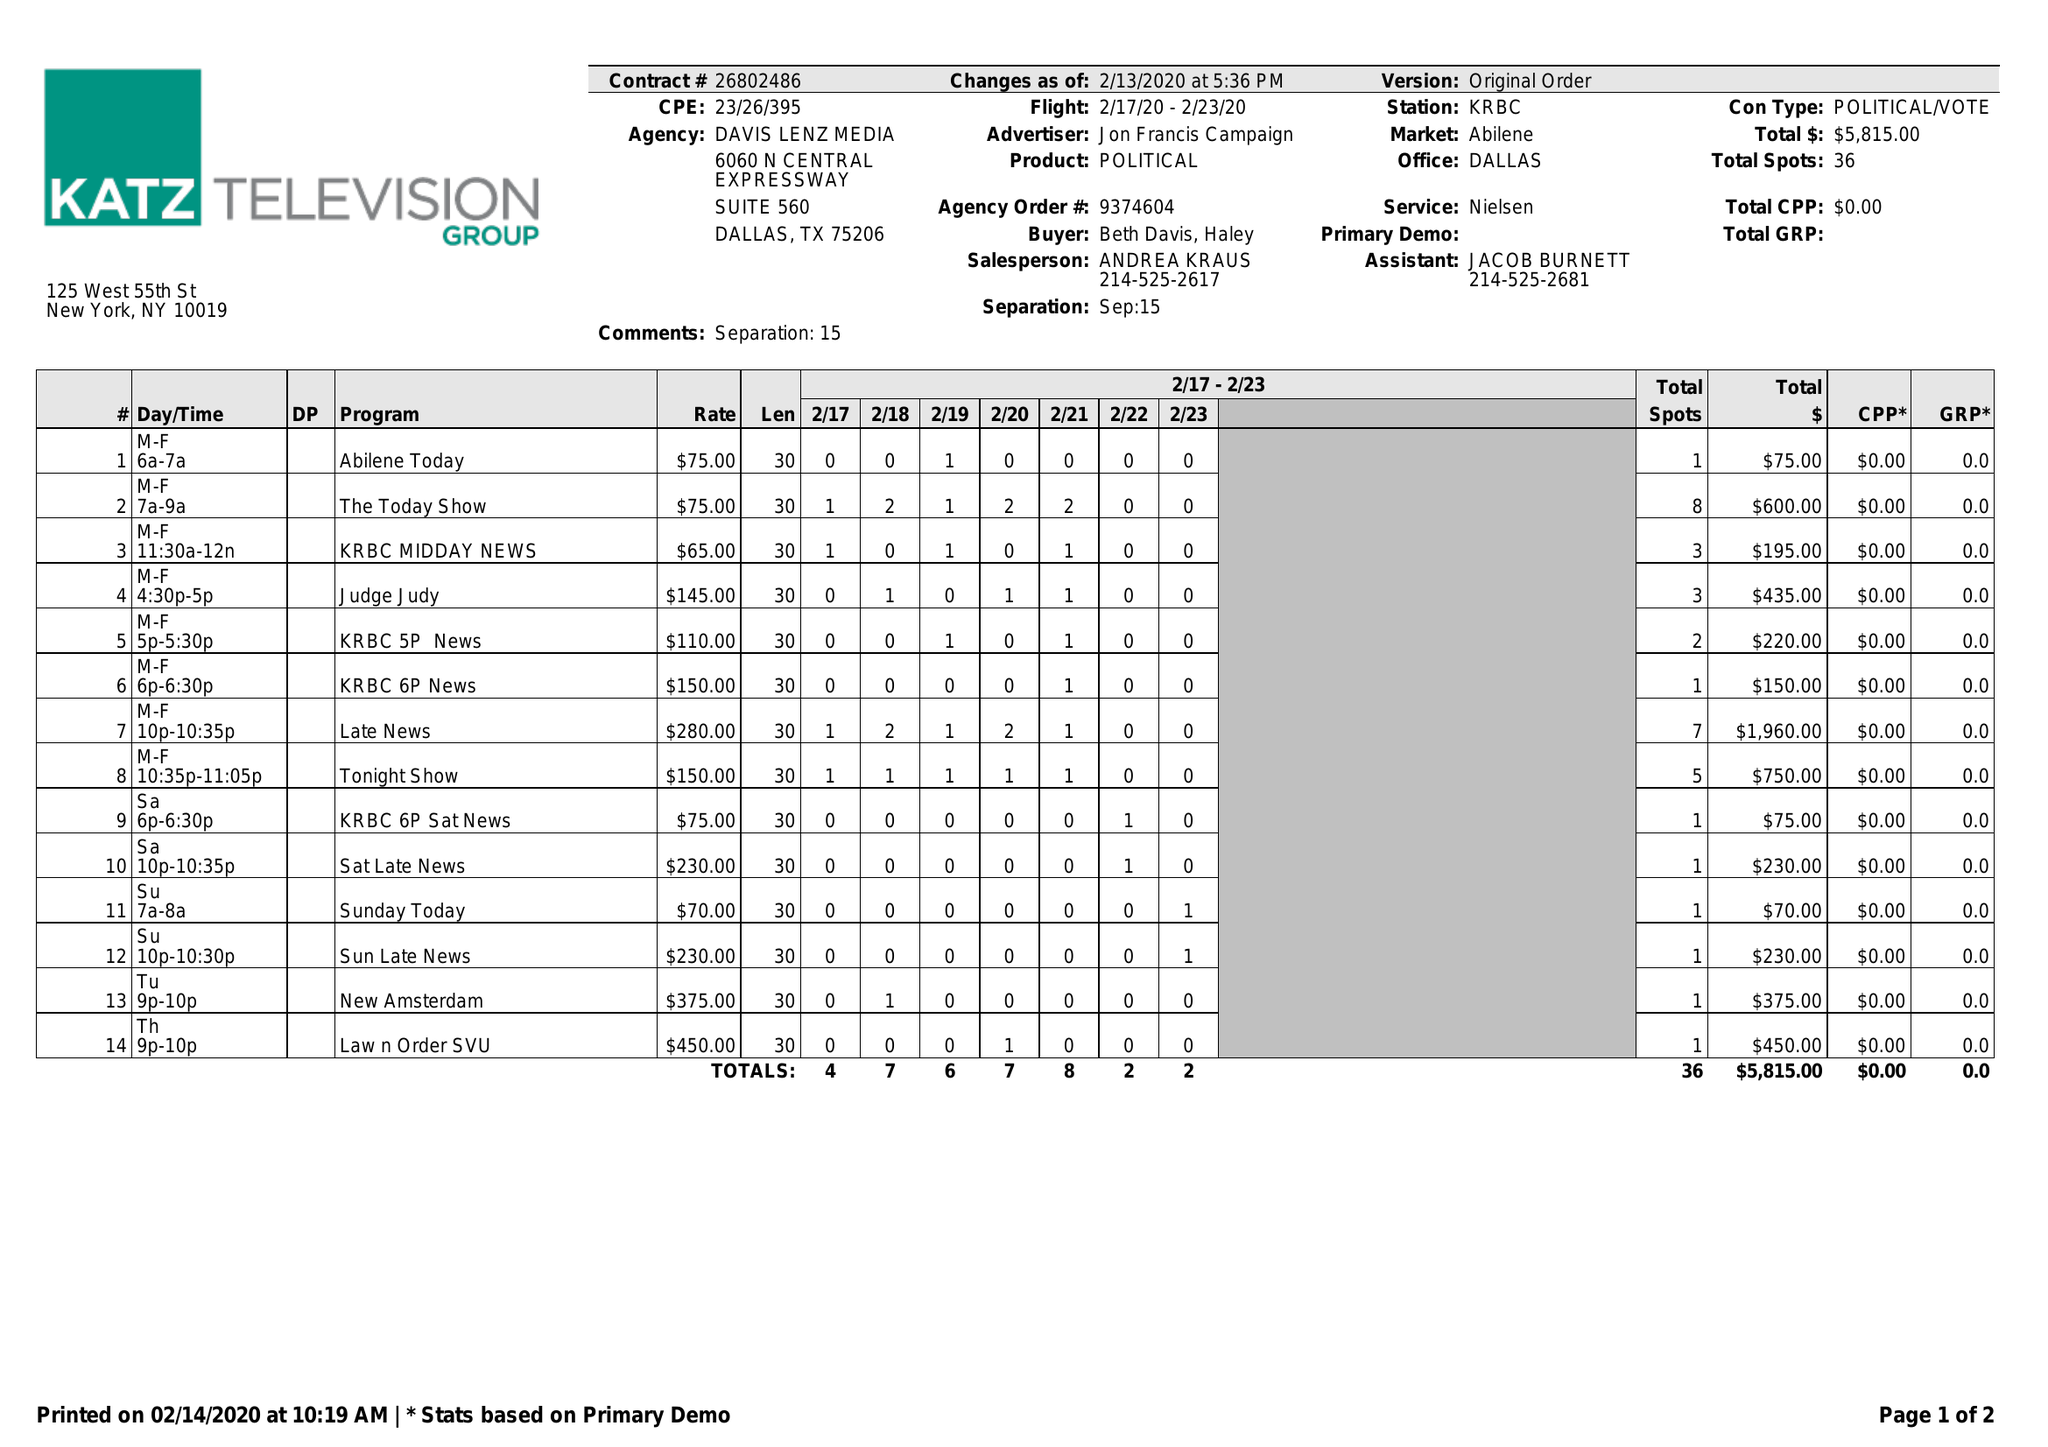What is the value for the gross_amount?
Answer the question using a single word or phrase. 5815.00 